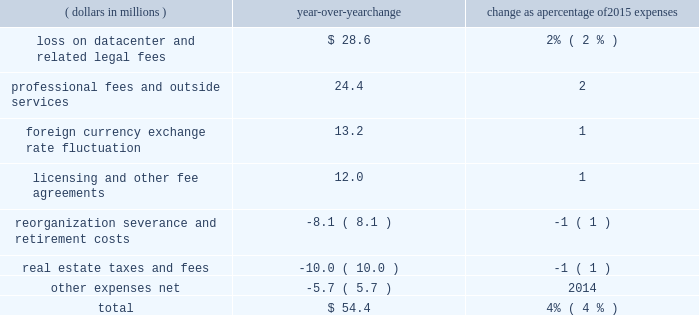Recognized total losses and expenses of $ 28.6 million , including a net loss on write-down to fair value of the assets and certain other transaction fees of $ 27.1 million within other expenses and $ 1.5 million of legal and other fees .
2022 professional fees and outside services expense decreased in 2017 compared to 2016 , largely due to higher legal and regulatory fees in 2016 related to our business activities and product offerings as well as higher professional fees related to a greater reliance on consultants for security and systems enhancement work .
The overall decrease in operating expenses in 2017 when compared with 2016 was partially offset by the following increases : 2022 licensing and other fee sharing agreements expense increased due to higher expense resulting from incentive payments made to facilitate the transition of the russell contract open interest , as well as increased costs of revenue sharing agreements for certain licensed products .
The overall increase in 2017 was partially offset by lower expense related to revenue sharing agreements for certain equity and energy contracts due to lower volume for these products compared to 2016 .
2022 compensation and benefits expense increased as a result of higher average headcount primarily in our international locations as well as normal cost of living adjustments .
2016 compared with 2015 operating expenses increased by $ 54.4 million in 2016 when compared with 2015 .
The table shows the estimated impact of key factors resulting in the net decrease in operating expenses .
( dollars in millions ) over-year change change as a percentage of 2015 expenses .
Overall operating expenses increased in 2016 when compared with 2015 due to the following reasons : 2022 in 2016 , we recognized total losses and expenses of $ 28.6 million , including a net loss on write-down to fair value of the assets and certain other transaction fees of $ 27.1 million within other expenses and $ 1.5 million of legal and other fees as a result of our sale and leaseback of our datacenter .
2022 professional fees and outside services expense increased in 2016 largely due to an increase in legal and regulatory efforts related to our business activities and product offerings as well as an increase in professional fees related to a greater reliance on consultants for security and systems enhancement work .
2022 in 2016 , we recognized a net loss of $ 24.5 million due to an unfavorable change in exchange rates on foreign cash balances , compared with a net loss of $ 11.3 million in 2015 .
2022 licensing and other fee sharing agreements expense increased due to higher expense related to revenue sharing agreements for certain equity and energy contracts due to both higher volume and an increase in license rates for certain equity and energy products. .
What was the ratio of the net loss in 2016 to 2015? 
Computations: (24.5 / 11.3)
Answer: 2.16814. 